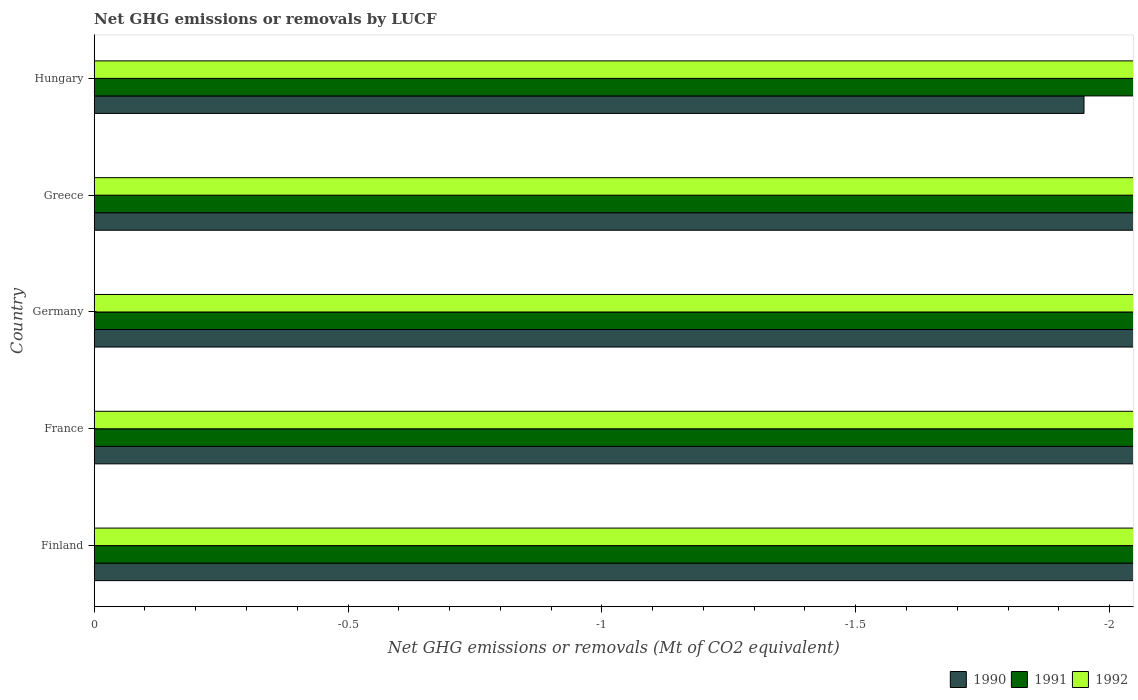Are the number of bars per tick equal to the number of legend labels?
Your answer should be compact. No. Are the number of bars on each tick of the Y-axis equal?
Offer a very short reply. Yes. How many bars are there on the 5th tick from the bottom?
Make the answer very short. 0. What is the label of the 5th group of bars from the top?
Give a very brief answer. Finland. In how many cases, is the number of bars for a given country not equal to the number of legend labels?
Ensure brevity in your answer.  5. What is the average net GHG emissions or removals by LUCF in 1991 per country?
Your response must be concise. 0. Are the values on the major ticks of X-axis written in scientific E-notation?
Your answer should be very brief. No. Does the graph contain any zero values?
Your answer should be very brief. Yes. Where does the legend appear in the graph?
Offer a very short reply. Bottom right. How many legend labels are there?
Offer a very short reply. 3. What is the title of the graph?
Your answer should be very brief. Net GHG emissions or removals by LUCF. Does "1987" appear as one of the legend labels in the graph?
Your answer should be very brief. No. What is the label or title of the X-axis?
Your answer should be compact. Net GHG emissions or removals (Mt of CO2 equivalent). What is the label or title of the Y-axis?
Your response must be concise. Country. What is the Net GHG emissions or removals (Mt of CO2 equivalent) in 1990 in Finland?
Your answer should be very brief. 0. What is the Net GHG emissions or removals (Mt of CO2 equivalent) in 1991 in Finland?
Give a very brief answer. 0. What is the Net GHG emissions or removals (Mt of CO2 equivalent) in 1990 in France?
Give a very brief answer. 0. What is the Net GHG emissions or removals (Mt of CO2 equivalent) in 1992 in France?
Provide a succinct answer. 0. What is the Net GHG emissions or removals (Mt of CO2 equivalent) in 1990 in Germany?
Offer a very short reply. 0. What is the Net GHG emissions or removals (Mt of CO2 equivalent) in 1991 in Germany?
Offer a very short reply. 0. What is the Net GHG emissions or removals (Mt of CO2 equivalent) of 1990 in Greece?
Your answer should be compact. 0. What is the Net GHG emissions or removals (Mt of CO2 equivalent) of 1991 in Greece?
Make the answer very short. 0. What is the Net GHG emissions or removals (Mt of CO2 equivalent) in 1992 in Greece?
Keep it short and to the point. 0. What is the Net GHG emissions or removals (Mt of CO2 equivalent) in 1990 in Hungary?
Your answer should be compact. 0. What is the total Net GHG emissions or removals (Mt of CO2 equivalent) of 1990 in the graph?
Keep it short and to the point. 0. What is the total Net GHG emissions or removals (Mt of CO2 equivalent) in 1991 in the graph?
Offer a very short reply. 0. What is the average Net GHG emissions or removals (Mt of CO2 equivalent) of 1990 per country?
Offer a terse response. 0. What is the average Net GHG emissions or removals (Mt of CO2 equivalent) in 1991 per country?
Offer a terse response. 0. What is the average Net GHG emissions or removals (Mt of CO2 equivalent) in 1992 per country?
Your response must be concise. 0. 